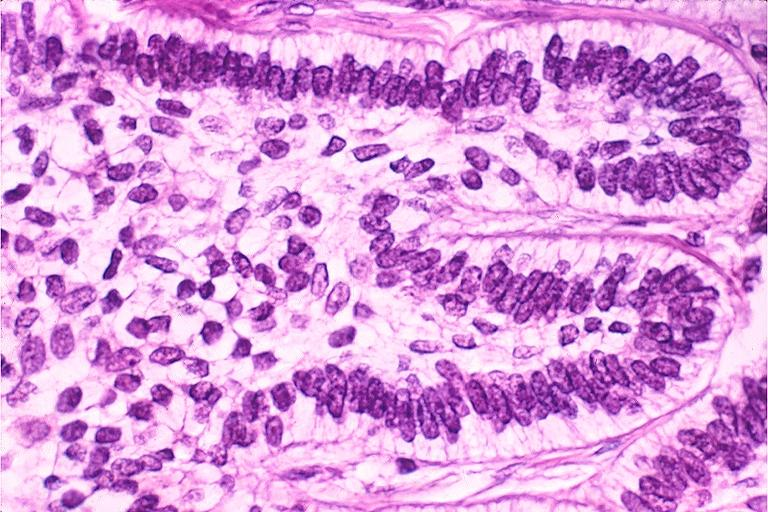does saggital section sternum with typical plasmacytoma show ameloblastoma?
Answer the question using a single word or phrase. No 